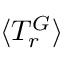<formula> <loc_0><loc_0><loc_500><loc_500>\langle T _ { r } ^ { G } \rangle</formula> 